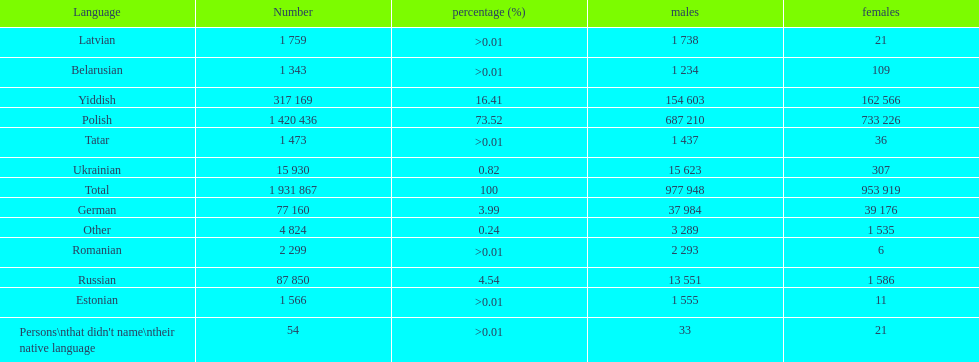Is german above or below russia in the number of people who speak that language? Below. 